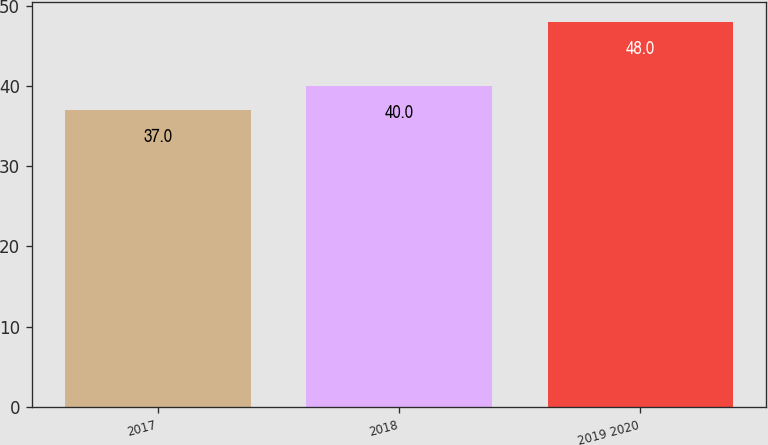Convert chart to OTSL. <chart><loc_0><loc_0><loc_500><loc_500><bar_chart><fcel>2017<fcel>2018<fcel>2019 2020<nl><fcel>37<fcel>40<fcel>48<nl></chart> 